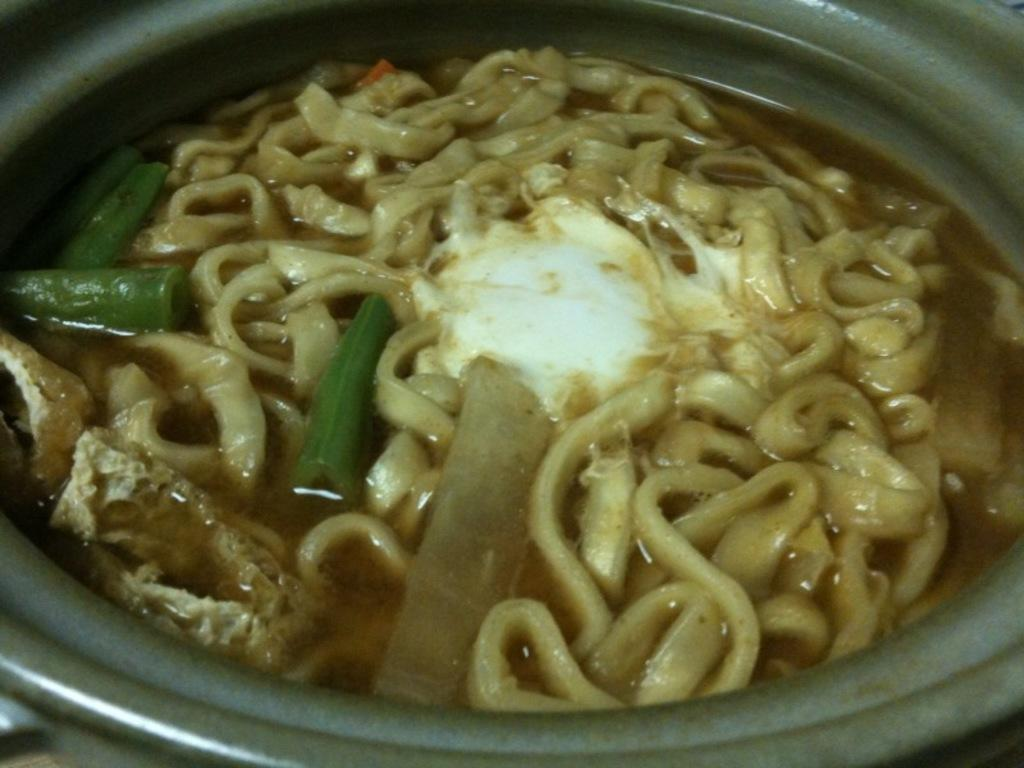What is in the bowl that is visible in the image? There are food items in a bowl in the image. What type of wrench is being used to push the food items in the image? There is no wrench or pushing action present in the image; it simply shows food items in a bowl. 